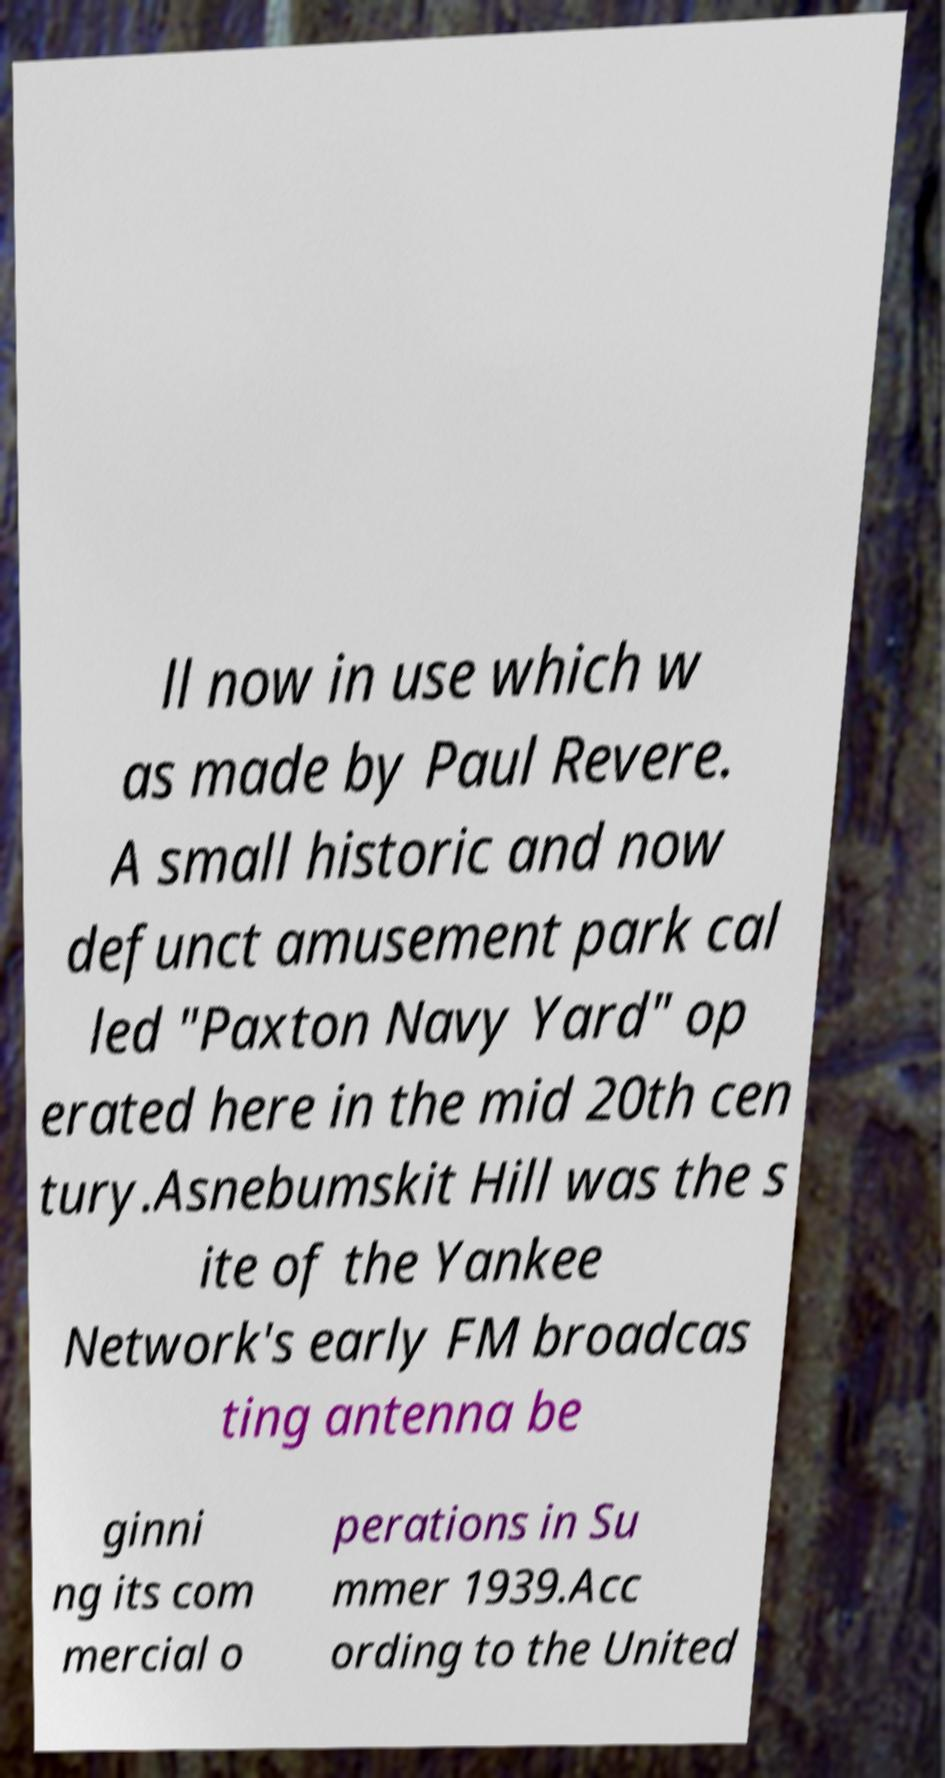For documentation purposes, I need the text within this image transcribed. Could you provide that? ll now in use which w as made by Paul Revere. A small historic and now defunct amusement park cal led "Paxton Navy Yard" op erated here in the mid 20th cen tury.Asnebumskit Hill was the s ite of the Yankee Network's early FM broadcas ting antenna be ginni ng its com mercial o perations in Su mmer 1939.Acc ording to the United 